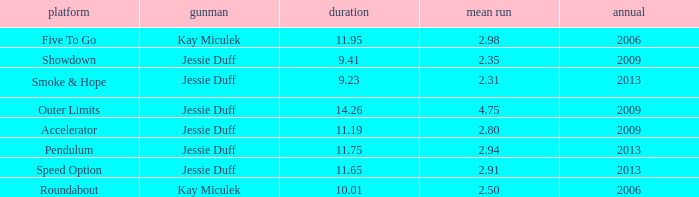What is the total amount of time for years prior to 2013 when speed option is the stage? None. 